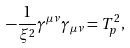Convert formula to latex. <formula><loc_0><loc_0><loc_500><loc_500>- \frac { 1 } { \xi ^ { 2 } } \gamma ^ { \mu \nu } \gamma _ { \mu \nu } = T _ { p } ^ { 2 } ,</formula> 